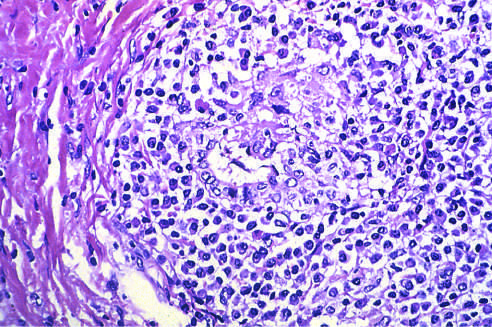s a portal tract markedly expanded by an infiltrate of lymphocytes and plasma cells?
Answer the question using a single word or phrase. Yes 